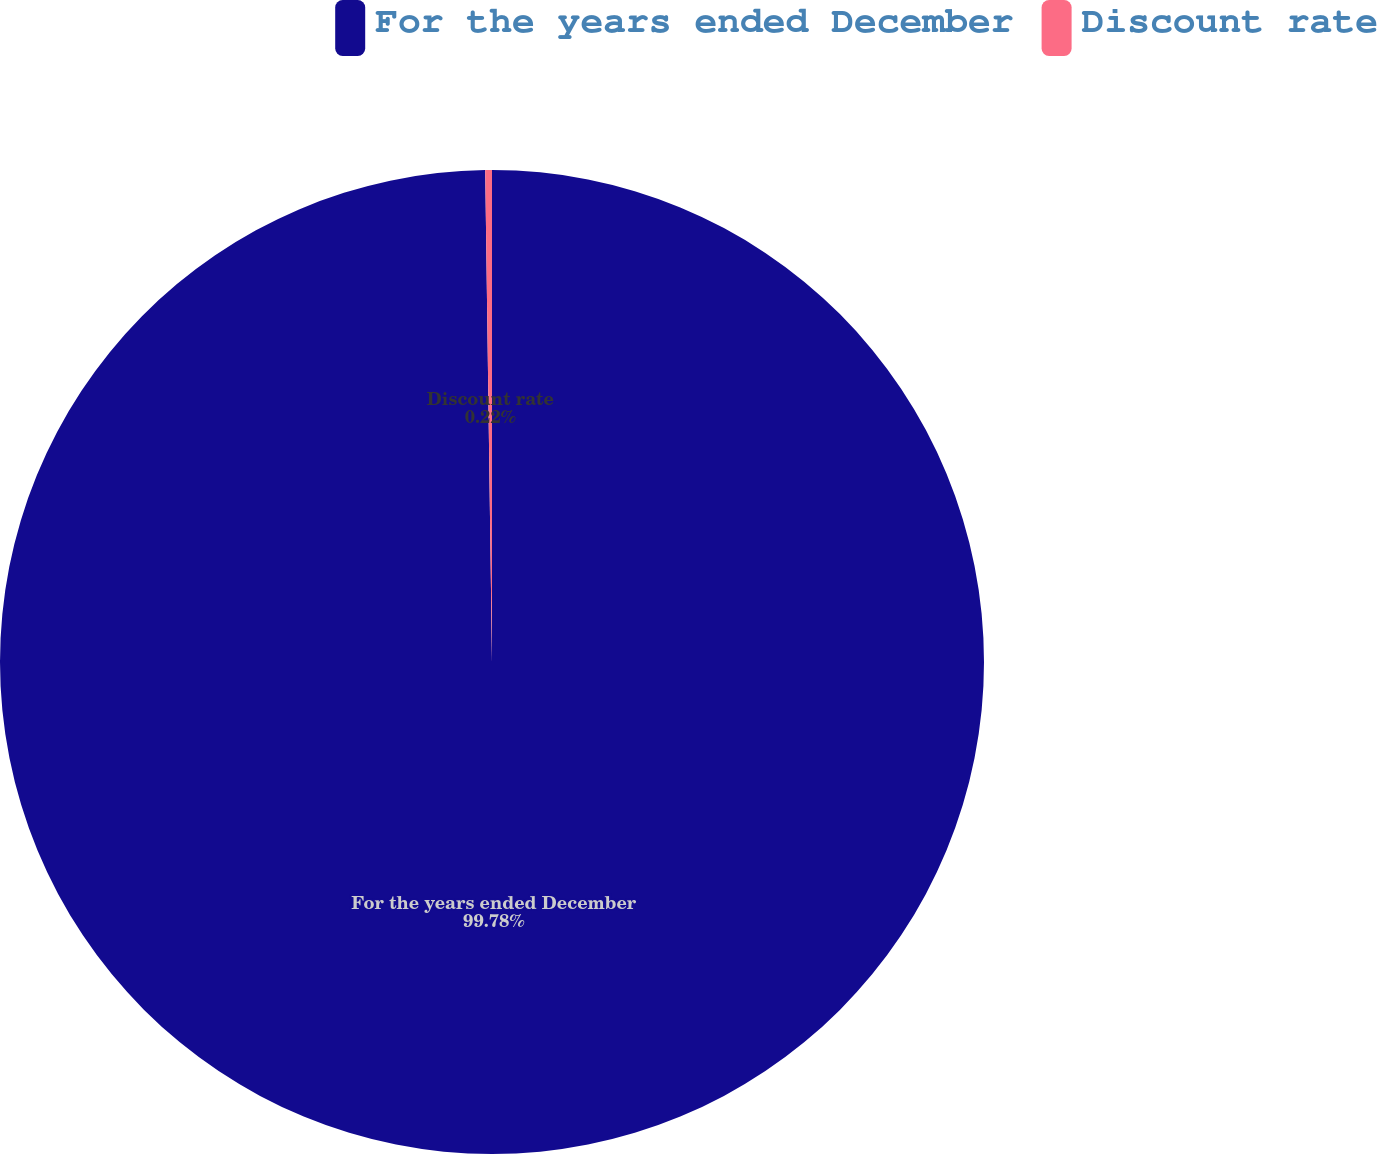Convert chart. <chart><loc_0><loc_0><loc_500><loc_500><pie_chart><fcel>For the years ended December<fcel>Discount rate<nl><fcel>99.78%<fcel>0.22%<nl></chart> 